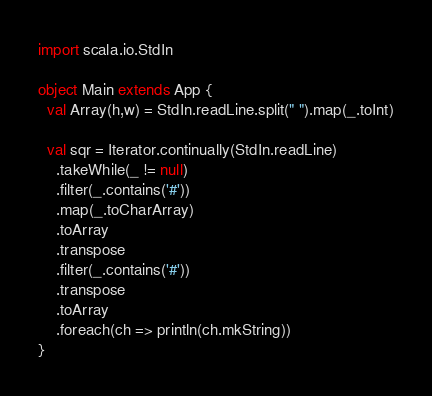Convert code to text. <code><loc_0><loc_0><loc_500><loc_500><_Scala_>import scala.io.StdIn

object Main extends App {
  val Array(h,w) = StdIn.readLine.split(" ").map(_.toInt)

  val sqr = Iterator.continually(StdIn.readLine)
    .takeWhile(_ != null)
    .filter(_.contains('#'))
    .map(_.toCharArray)
    .toArray
    .transpose
    .filter(_.contains('#'))
    .transpose
    .toArray
    .foreach(ch => println(ch.mkString))
}</code> 